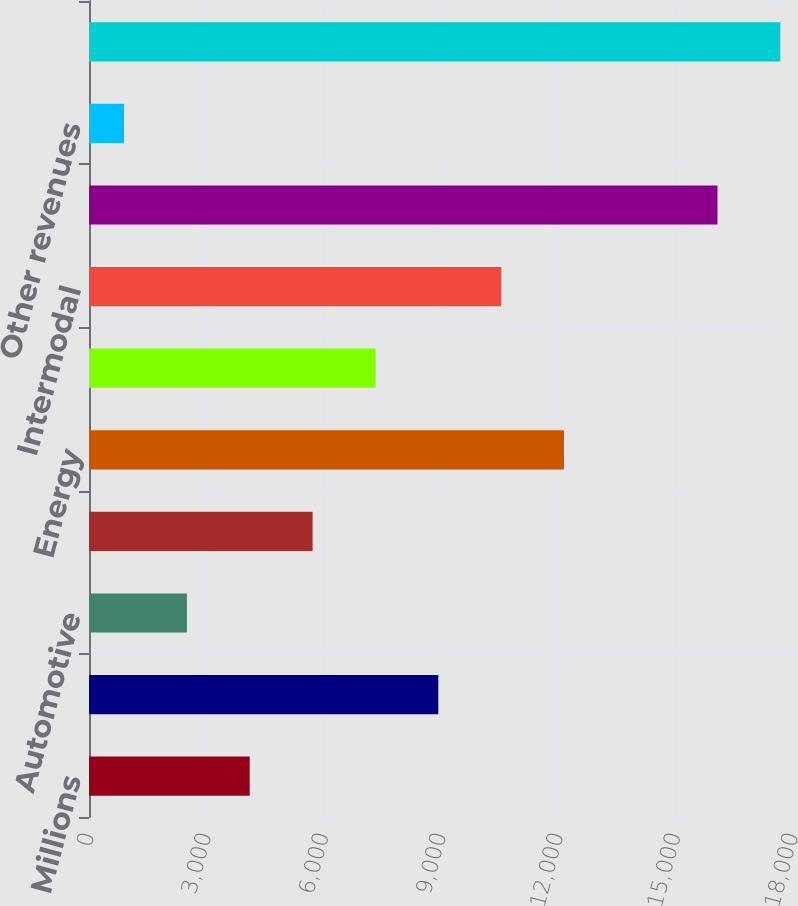<chart> <loc_0><loc_0><loc_500><loc_500><bar_chart><fcel>Millions<fcel>Agricultural<fcel>Automotive<fcel>Chemicals<fcel>Energy<fcel>Industrial Products<fcel>Intermodal<fcel>Total freight revenues<fcel>Other revenues<fcel>Total operating revenues<nl><fcel>4109.8<fcel>8930.5<fcel>2502.9<fcel>5716.7<fcel>12144.3<fcel>7323.6<fcel>10537.4<fcel>16069<fcel>896<fcel>17675.9<nl></chart> 